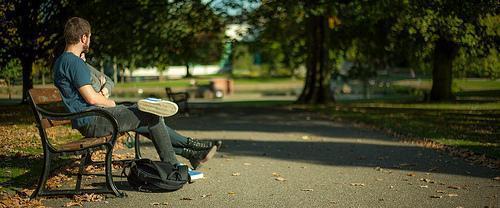How many bookbags are in the photo?
Give a very brief answer. 1. How many people are on the bench?
Give a very brief answer. 2. How many people are pictured?
Give a very brief answer. 2. How many people have their leg resting on their knee?
Give a very brief answer. 1. 